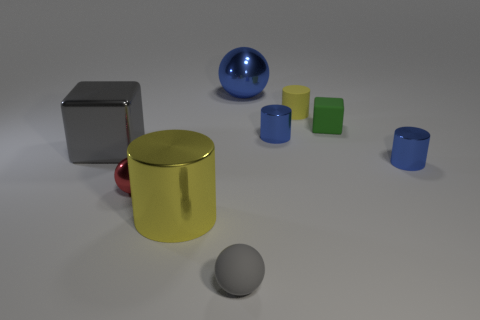What can you infer about the lighting in this scene? The lighting in the scene seems diffused and uniform, likely from an overhead source given the soft and subtle shadows cast by the objects. The absence of harsh shadows or bright highlights suggests an ambient light setup, common in visualization or photography to minimize glare and provide even illumination. 